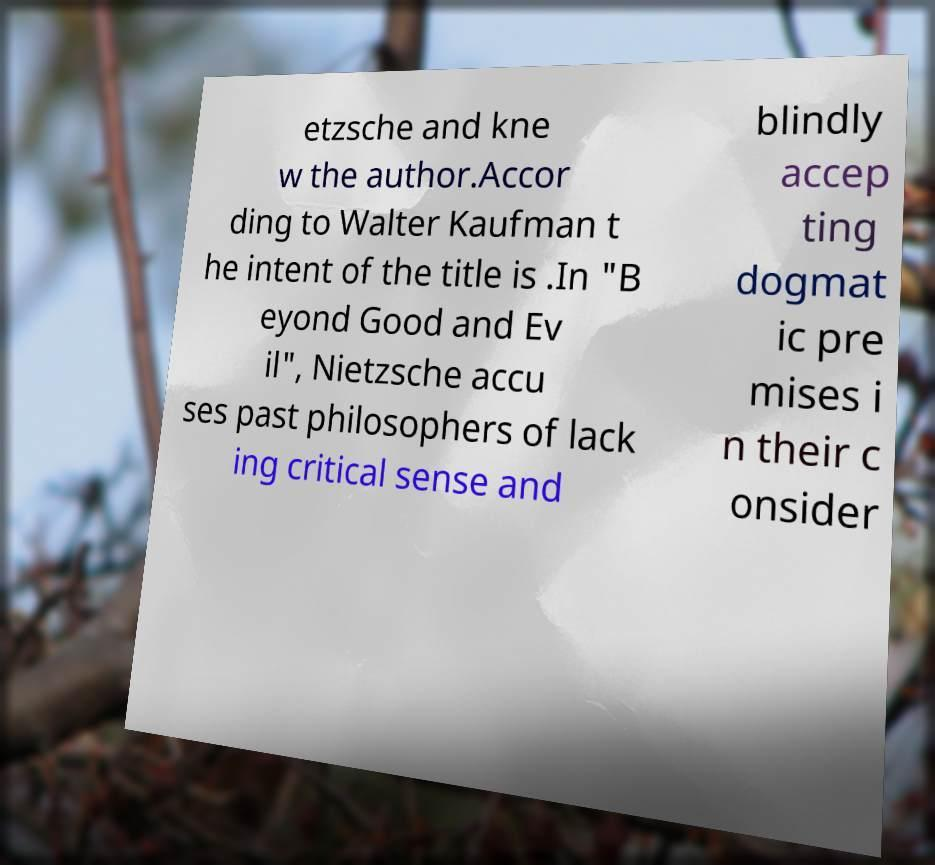What messages or text are displayed in this image? I need them in a readable, typed format. etzsche and kne w the author.Accor ding to Walter Kaufman t he intent of the title is .In "B eyond Good and Ev il", Nietzsche accu ses past philosophers of lack ing critical sense and blindly accep ting dogmat ic pre mises i n their c onsider 